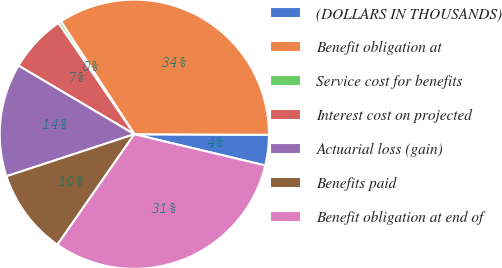<chart> <loc_0><loc_0><loc_500><loc_500><pie_chart><fcel>(DOLLARS IN THOUSANDS)<fcel>Benefit obligation at<fcel>Service cost for benefits<fcel>Interest cost on projected<fcel>Actuarial loss (gain)<fcel>Benefits paid<fcel>Benefit obligation at end of<nl><fcel>3.66%<fcel>34.25%<fcel>0.35%<fcel>6.96%<fcel>13.57%<fcel>10.26%<fcel>30.95%<nl></chart> 